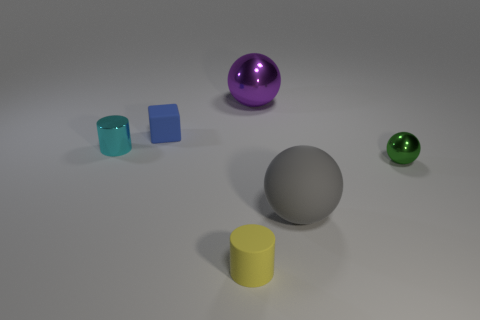What colors are the objects in the image? The objects display a variety of colors: there is a purple sphere, a blue cube, a gray sphere, a yellow cylinder, and a green sphere. Do the colors of these objects suggest anything about the atmosphere or setting of the image? The colors of the objects do not strongly suggest a specific atmosphere or setting, as they are typical for geometric shapes used in visual or design concepts. They provide a neutral and clean aesthetic that focuses on form and color rather than context. 